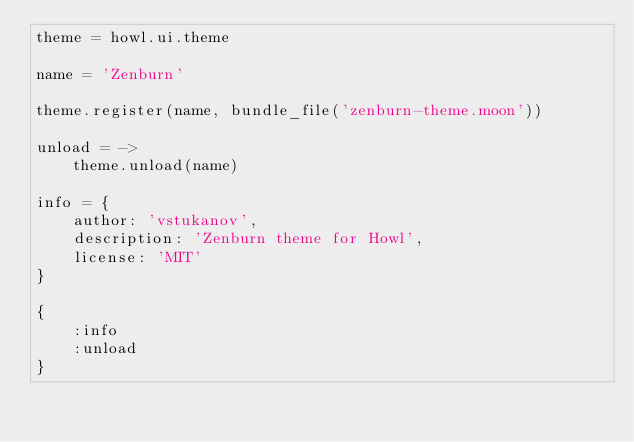Convert code to text. <code><loc_0><loc_0><loc_500><loc_500><_MoonScript_>theme = howl.ui.theme

name = 'Zenburn'

theme.register(name, bundle_file('zenburn-theme.moon'))

unload = ->
    theme.unload(name)

info = {
    author: 'vstukanov',
    description: 'Zenburn theme for Howl',
    license: 'MIT'
}

{
    :info
    :unload
}
</code> 